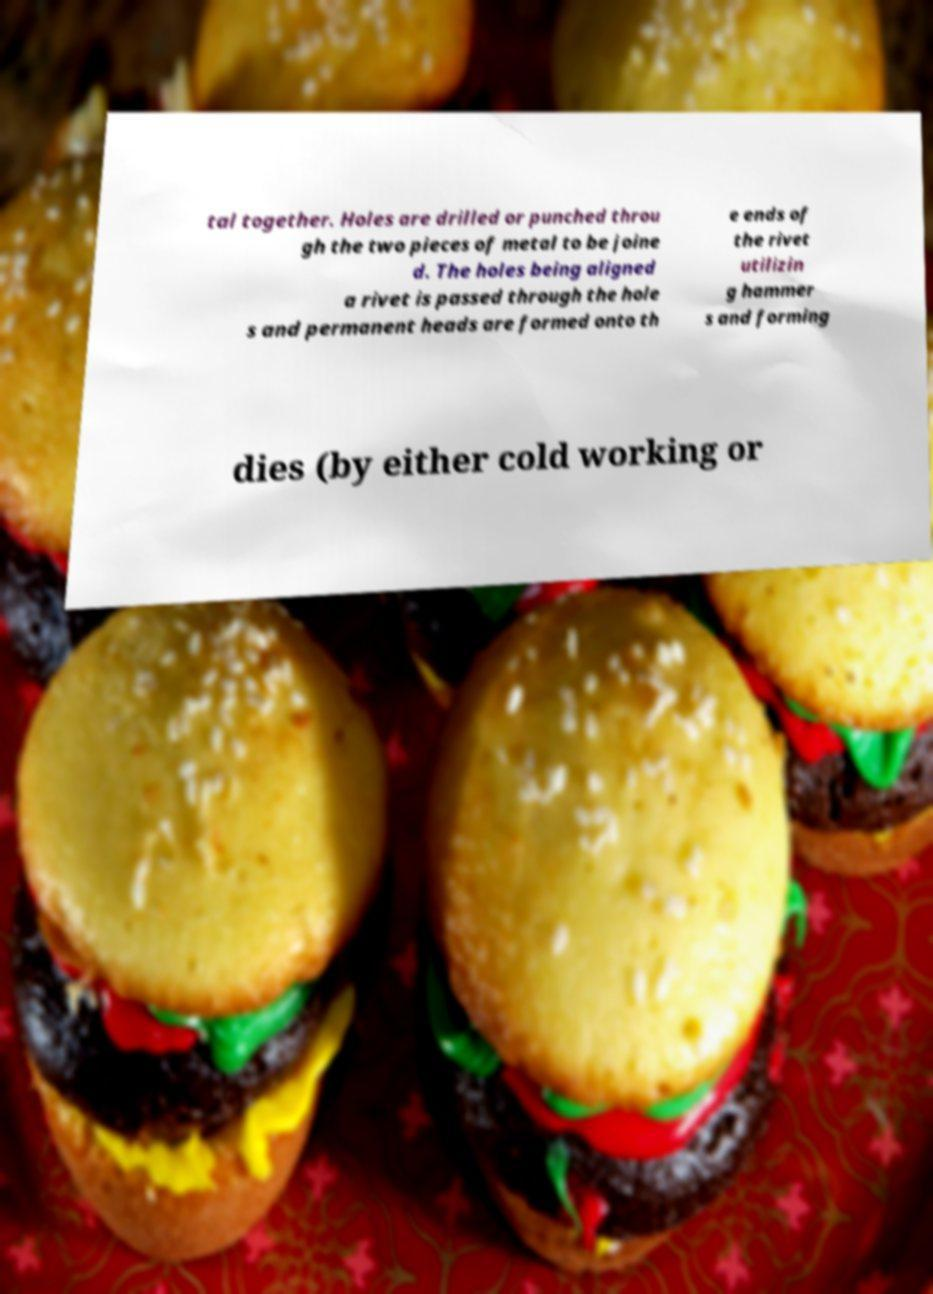There's text embedded in this image that I need extracted. Can you transcribe it verbatim? tal together. Holes are drilled or punched throu gh the two pieces of metal to be joine d. The holes being aligned a rivet is passed through the hole s and permanent heads are formed onto th e ends of the rivet utilizin g hammer s and forming dies (by either cold working or 